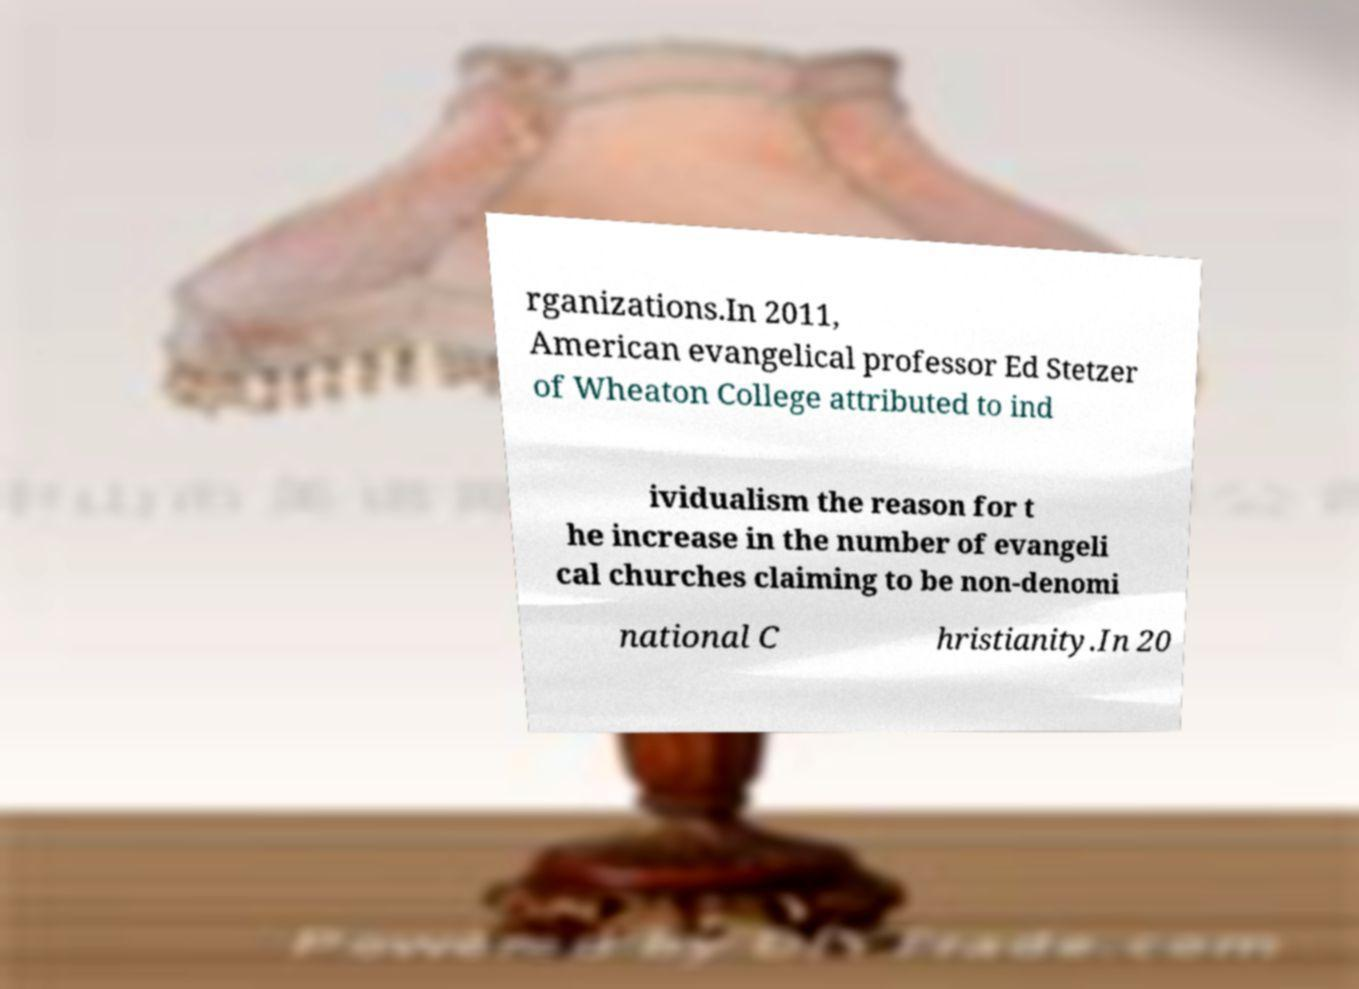Can you accurately transcribe the text from the provided image for me? rganizations.In 2011, American evangelical professor Ed Stetzer of Wheaton College attributed to ind ividualism the reason for t he increase in the number of evangeli cal churches claiming to be non-denomi national C hristianity.In 20 